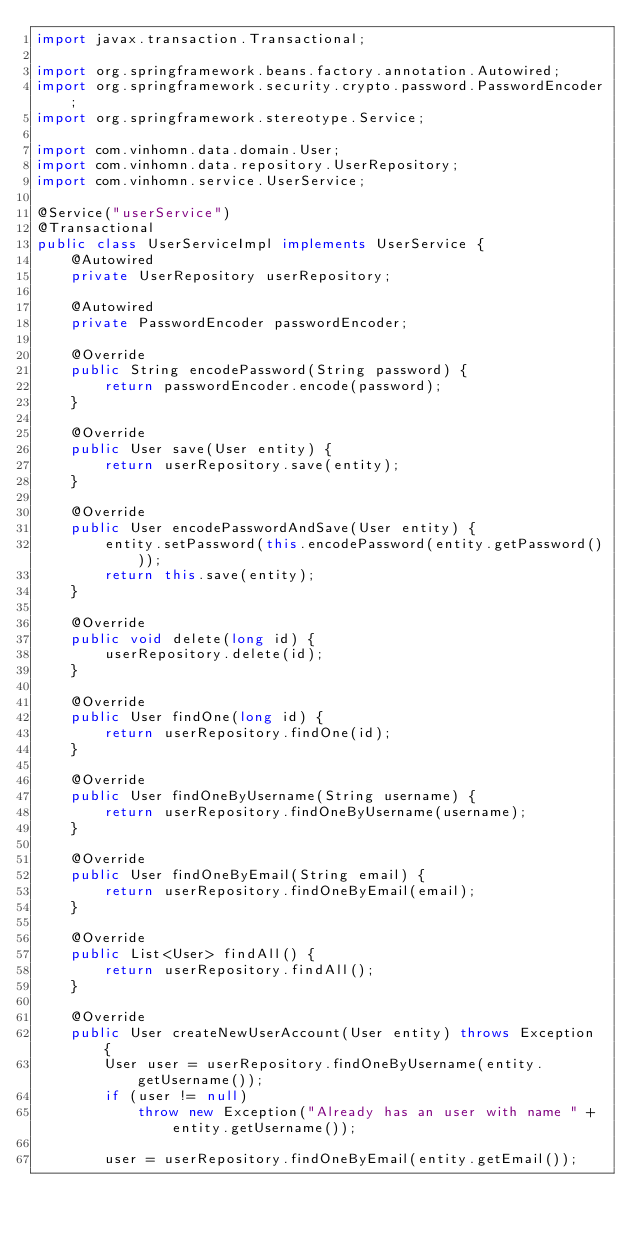<code> <loc_0><loc_0><loc_500><loc_500><_Java_>import javax.transaction.Transactional;

import org.springframework.beans.factory.annotation.Autowired;
import org.springframework.security.crypto.password.PasswordEncoder;
import org.springframework.stereotype.Service;

import com.vinhomn.data.domain.User;
import com.vinhomn.data.repository.UserRepository;
import com.vinhomn.service.UserService;

@Service("userService")
@Transactional
public class UserServiceImpl implements UserService {
    @Autowired
    private UserRepository userRepository;
    
    @Autowired
    private PasswordEncoder passwordEncoder;
    
    @Override
    public String encodePassword(String password) {
        return passwordEncoder.encode(password);
    }

    @Override
    public User save(User entity) {
        return userRepository.save(entity);
    }
    
    @Override
    public User encodePasswordAndSave(User entity) {
        entity.setPassword(this.encodePassword(entity.getPassword()));
        return this.save(entity);
    }

    @Override
    public void delete(long id) {
        userRepository.delete(id);
    }

    @Override
    public User findOne(long id) {
        return userRepository.findOne(id);
    }

    @Override
    public User findOneByUsername(String username) {
        return userRepository.findOneByUsername(username);
    }

    @Override
    public User findOneByEmail(String email) {
        return userRepository.findOneByEmail(email);
    }

    @Override
    public List<User> findAll() {
        return userRepository.findAll();
    }

    @Override
    public User createNewUserAccount(User entity) throws Exception {
        User user = userRepository.findOneByUsername(entity.getUsername());
        if (user != null) 
            throw new Exception("Already has an user with name " + entity.getUsername());
        
        user = userRepository.findOneByEmail(entity.getEmail());</code> 